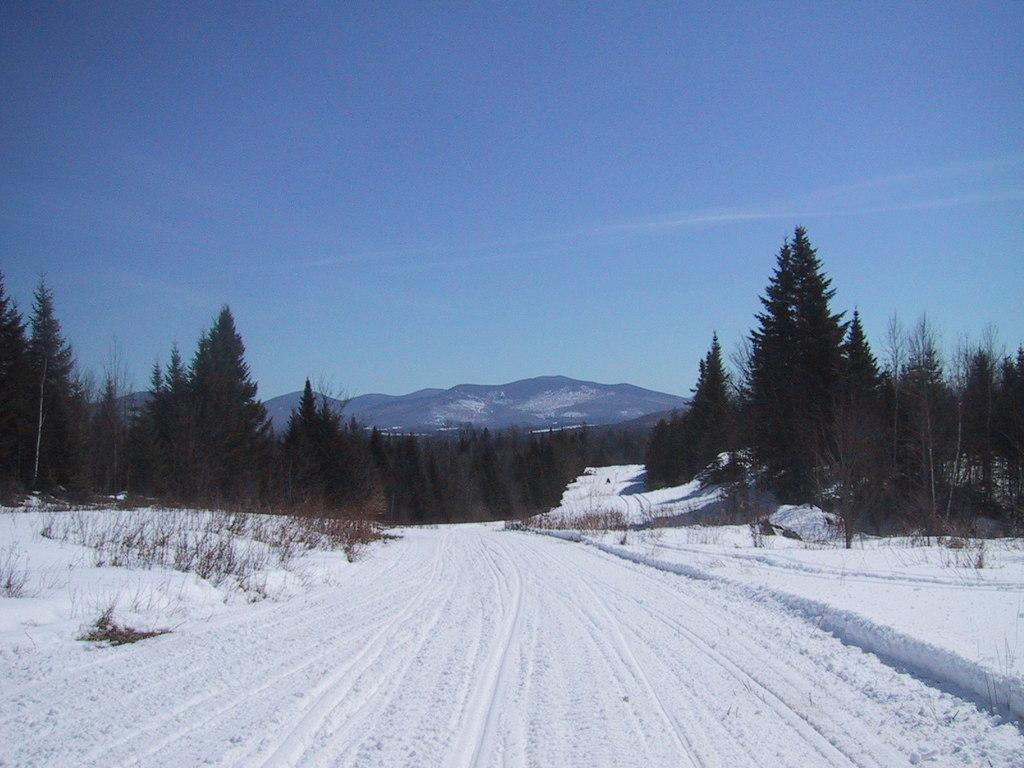What is covering the surface in the image? There is snow on the surface in the image. What can be seen in the background of the image? There are trees and mountains in the background of the image. What part of the natural environment is visible in the image? The sky is visible in the background of the image. What type of sofa can be seen in the image? There is no sofa present in the image. Can you tell me how many clovers are growing in the snow? There are no clovers visible in the image; it features snow-covered surfaces and a background with trees, mountains, and the sky. 